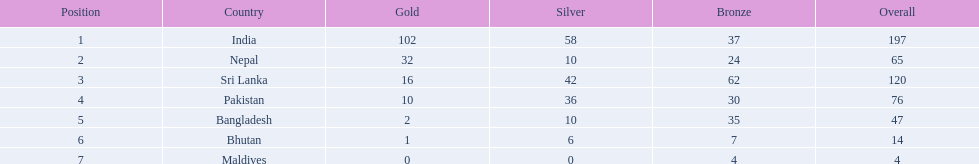What countries attended the 1999 south asian games? India, Nepal, Sri Lanka, Pakistan, Bangladesh, Bhutan, Maldives. Which of these countries had 32 gold medals? Nepal. 